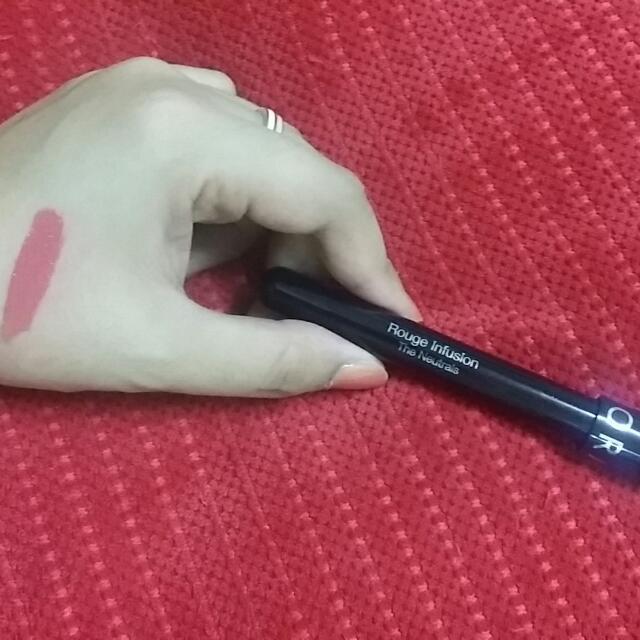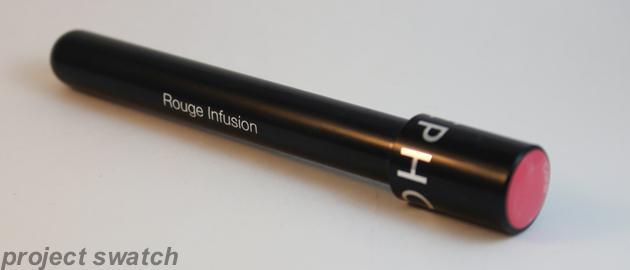The first image is the image on the left, the second image is the image on the right. Considering the images on both sides, is "The lipstick is shown on a person's lips in at least one of the images." valid? Answer yes or no. No. The first image is the image on the left, the second image is the image on the right. For the images displayed, is the sentence "There are three tubes of lipstick." factually correct? Answer yes or no. No. 